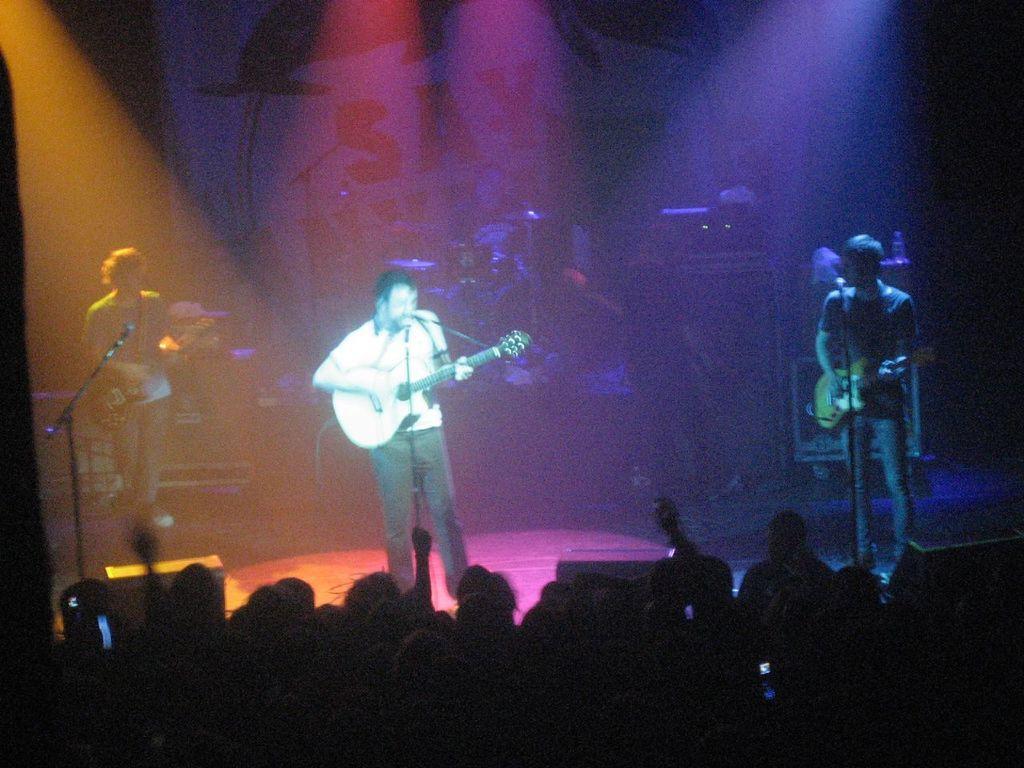Please provide a concise description of this image. This picture is clicked at a concert. In the center of the image there is a man standing and playing guitar. He is also singing. The man to the left corner and the man to the right corner are playing guitar. In front of them there are microphones. To the below of the image there are spectators. In the background there is wall with text on it. 